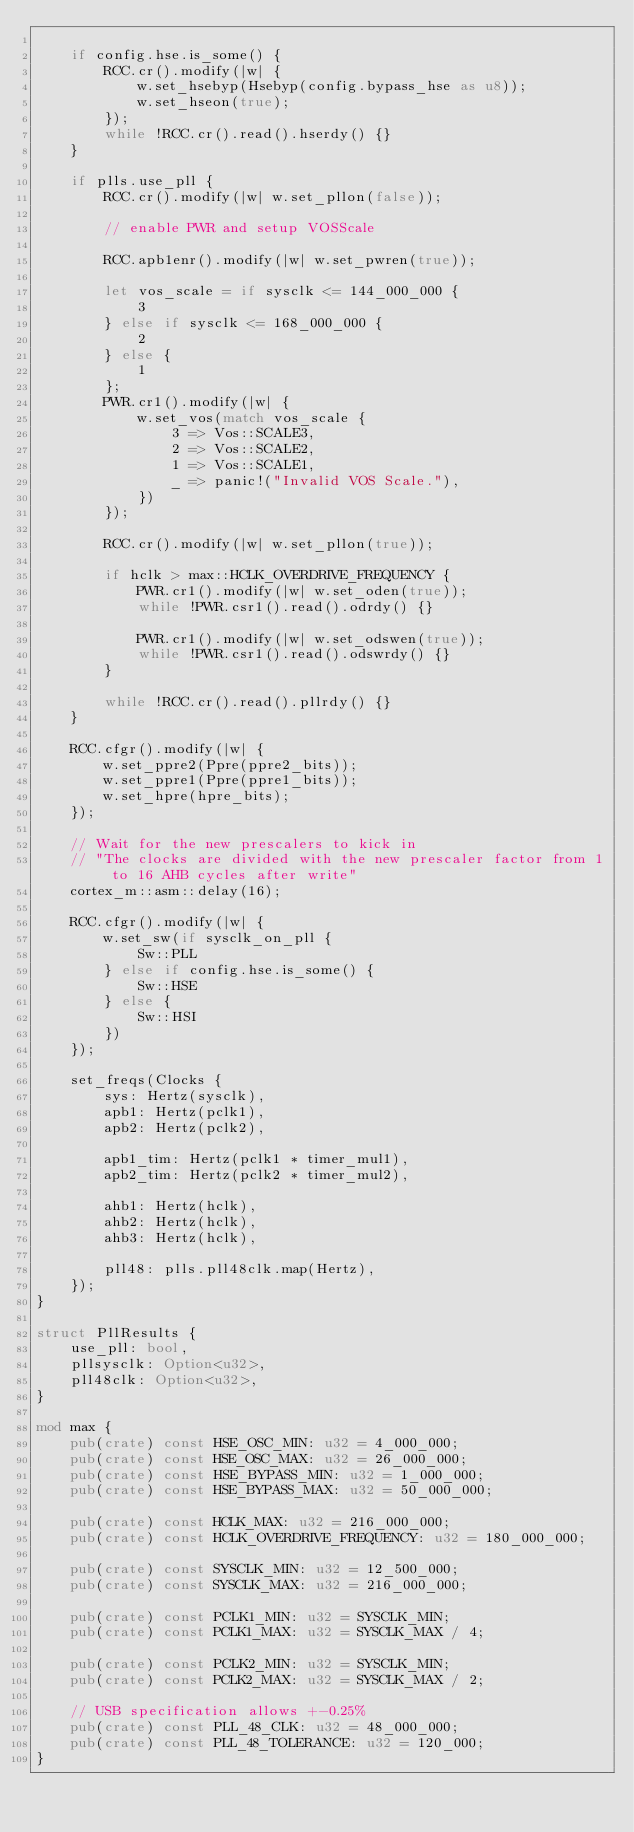Convert code to text. <code><loc_0><loc_0><loc_500><loc_500><_Rust_>
    if config.hse.is_some() {
        RCC.cr().modify(|w| {
            w.set_hsebyp(Hsebyp(config.bypass_hse as u8));
            w.set_hseon(true);
        });
        while !RCC.cr().read().hserdy() {}
    }

    if plls.use_pll {
        RCC.cr().modify(|w| w.set_pllon(false));

        // enable PWR and setup VOSScale

        RCC.apb1enr().modify(|w| w.set_pwren(true));

        let vos_scale = if sysclk <= 144_000_000 {
            3
        } else if sysclk <= 168_000_000 {
            2
        } else {
            1
        };
        PWR.cr1().modify(|w| {
            w.set_vos(match vos_scale {
                3 => Vos::SCALE3,
                2 => Vos::SCALE2,
                1 => Vos::SCALE1,
                _ => panic!("Invalid VOS Scale."),
            })
        });

        RCC.cr().modify(|w| w.set_pllon(true));

        if hclk > max::HCLK_OVERDRIVE_FREQUENCY {
            PWR.cr1().modify(|w| w.set_oden(true));
            while !PWR.csr1().read().odrdy() {}

            PWR.cr1().modify(|w| w.set_odswen(true));
            while !PWR.csr1().read().odswrdy() {}
        }

        while !RCC.cr().read().pllrdy() {}
    }

    RCC.cfgr().modify(|w| {
        w.set_ppre2(Ppre(ppre2_bits));
        w.set_ppre1(Ppre(ppre1_bits));
        w.set_hpre(hpre_bits);
    });

    // Wait for the new prescalers to kick in
    // "The clocks are divided with the new prescaler factor from 1 to 16 AHB cycles after write"
    cortex_m::asm::delay(16);

    RCC.cfgr().modify(|w| {
        w.set_sw(if sysclk_on_pll {
            Sw::PLL
        } else if config.hse.is_some() {
            Sw::HSE
        } else {
            Sw::HSI
        })
    });

    set_freqs(Clocks {
        sys: Hertz(sysclk),
        apb1: Hertz(pclk1),
        apb2: Hertz(pclk2),

        apb1_tim: Hertz(pclk1 * timer_mul1),
        apb2_tim: Hertz(pclk2 * timer_mul2),

        ahb1: Hertz(hclk),
        ahb2: Hertz(hclk),
        ahb3: Hertz(hclk),

        pll48: plls.pll48clk.map(Hertz),
    });
}

struct PllResults {
    use_pll: bool,
    pllsysclk: Option<u32>,
    pll48clk: Option<u32>,
}

mod max {
    pub(crate) const HSE_OSC_MIN: u32 = 4_000_000;
    pub(crate) const HSE_OSC_MAX: u32 = 26_000_000;
    pub(crate) const HSE_BYPASS_MIN: u32 = 1_000_000;
    pub(crate) const HSE_BYPASS_MAX: u32 = 50_000_000;

    pub(crate) const HCLK_MAX: u32 = 216_000_000;
    pub(crate) const HCLK_OVERDRIVE_FREQUENCY: u32 = 180_000_000;

    pub(crate) const SYSCLK_MIN: u32 = 12_500_000;
    pub(crate) const SYSCLK_MAX: u32 = 216_000_000;

    pub(crate) const PCLK1_MIN: u32 = SYSCLK_MIN;
    pub(crate) const PCLK1_MAX: u32 = SYSCLK_MAX / 4;

    pub(crate) const PCLK2_MIN: u32 = SYSCLK_MIN;
    pub(crate) const PCLK2_MAX: u32 = SYSCLK_MAX / 2;

    // USB specification allows +-0.25%
    pub(crate) const PLL_48_CLK: u32 = 48_000_000;
    pub(crate) const PLL_48_TOLERANCE: u32 = 120_000;
}
</code> 